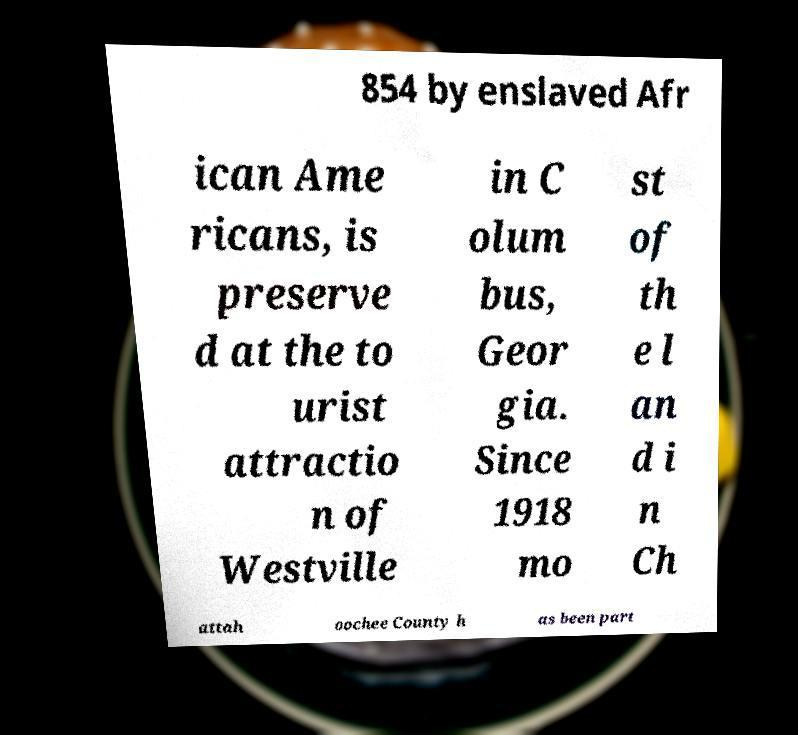Could you extract and type out the text from this image? 854 by enslaved Afr ican Ame ricans, is preserve d at the to urist attractio n of Westville in C olum bus, Geor gia. Since 1918 mo st of th e l an d i n Ch attah oochee County h as been part 